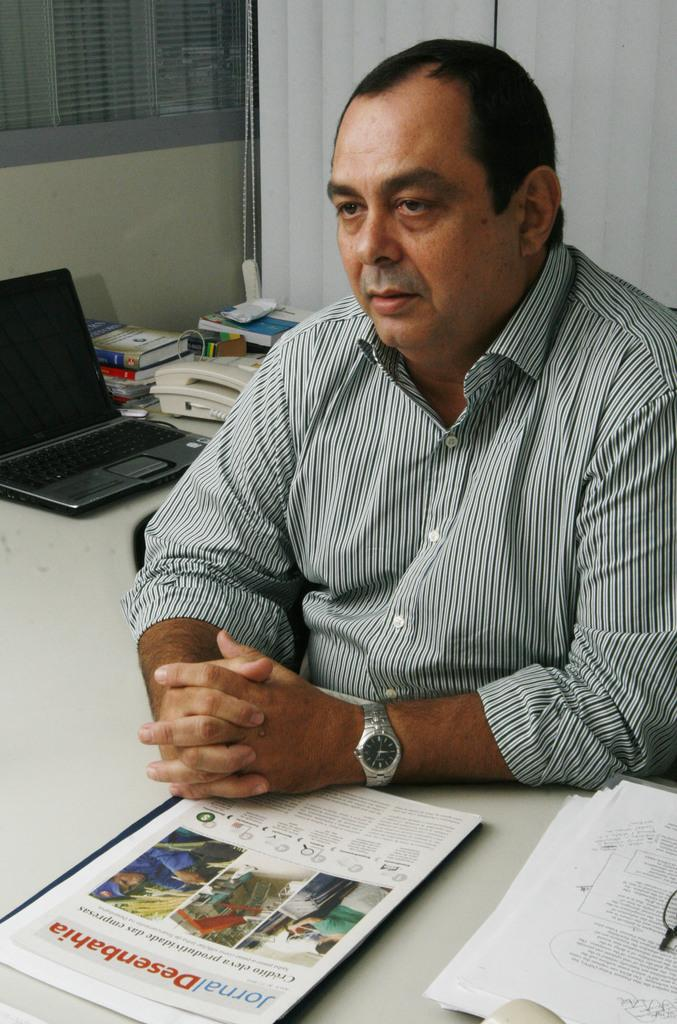<image>
Relay a brief, clear account of the picture shown. A man sits at a desk with a copy of Jornal Desenbahia in front of him. 